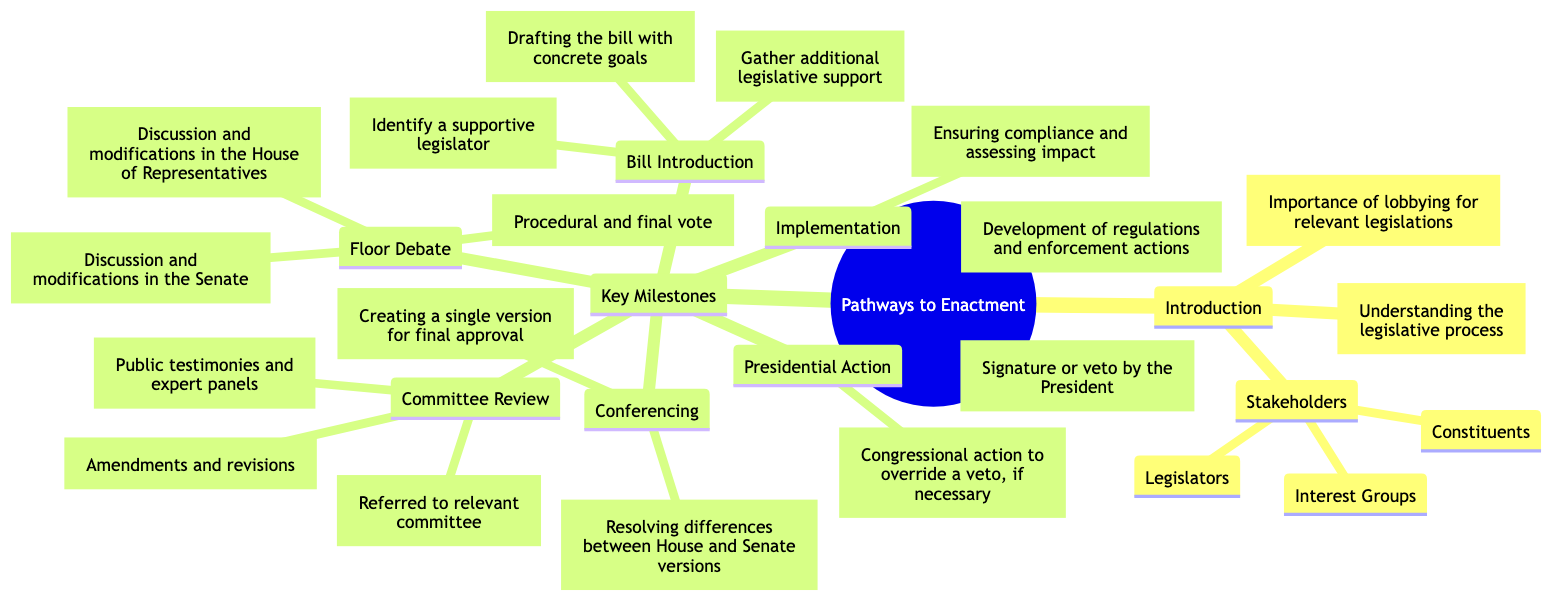What is the purpose of the diagram? The purpose of the diagram is specified in the "Introduction" section, which states its importance regarding lobbying for relevant legislations.
Answer: Importance of lobbying for relevant legislations How many key milestones are identified in the diagram? The "Key Milestones" section lists five distinct milestones: Bill Introduction, Committee Review, Floor Debate, Conferencing, and Presidential Action. Therefore, counting these gives a total of five.
Answer: 5 Which stakeholders are mentioned in the diagram? The "Stakeholders" section under "Introduction" lists three stakeholders: Legislators, Interest Groups, and Constituents.
Answer: Legislators, Interest Groups, Constituents What is the focus of the "Committee Review" phase? The "Committee Review" phase includes Committee Assignment, Hearings, and Mark-Up Sessions, reflecting the main activities during Committee Review.
Answer: Committee Assignment, Hearings, Mark-Up Sessions What action follows the "Vote" in the legislative process? Following the "Vote," the next major action is "Conferencing," which entails creating a unified bill from the House and Senate versions.
Answer: Conferencing Which step involves public testimonies? The step that involves public testimonies is "Hearings," which is part of the "Committee Review" process.
Answer: Hearings How does a bill reach Presidential Action? A bill reaches "Presidential Action" after completing the "Floor Debate" where a vote is conducted, leading to the subsequent step of Presidential Approval. It involves passing through various stages of the legislative process.
Answer: Presidential Approval What is needed for a bill to become unified? A "Unified Bill" is created by the "Conference Committee" during the "Conferencing" phase, where House and Senate differences are resolved.
Answer: Conference Committee What follows after 'Administrative Action' in the implementation of legislation? After "Administrative Action," the next step is "Ongoing Monitoring" to ensure compliance and assess the impact of the legislation.
Answer: Ongoing Monitoring 